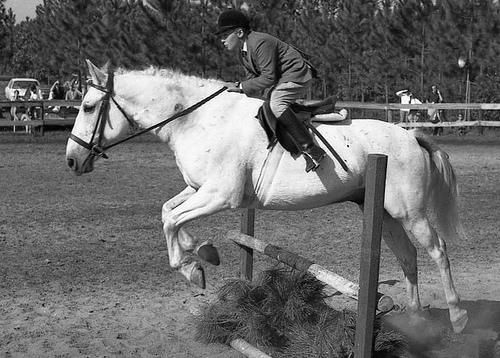Question: what is the horse jumping over?
Choices:
A. A rock.
B. Wooden hurdle.
C. A tree.
D. A puddle.
Answer with the letter. Answer: B Question: how many hats are visible in the photo?
Choices:
A. Two.
B. Three.
C. One.
D. Four.
Answer with the letter. Answer: C Question: where is this scene taking place?
Choices:
A. Horse show.
B. Dog Show.
C. Hair Show.
D. Spelling Bee.
Answer with the letter. Answer: A Question: when is this scene taking place?
Choices:
A. Daytime.
B. Night time.
C. Morning.
D. Afternoon.
Answer with the letter. Answer: A Question: who is riding the horse?
Choices:
A. Cowboy.
B. Rancher.
C. A child.
D. Jockey.
Answer with the letter. Answer: D Question: where is the horse?
Choices:
A. Pasture.
B. Barnyard.
C. Field.
D. Paddock.
Answer with the letter. Answer: C 